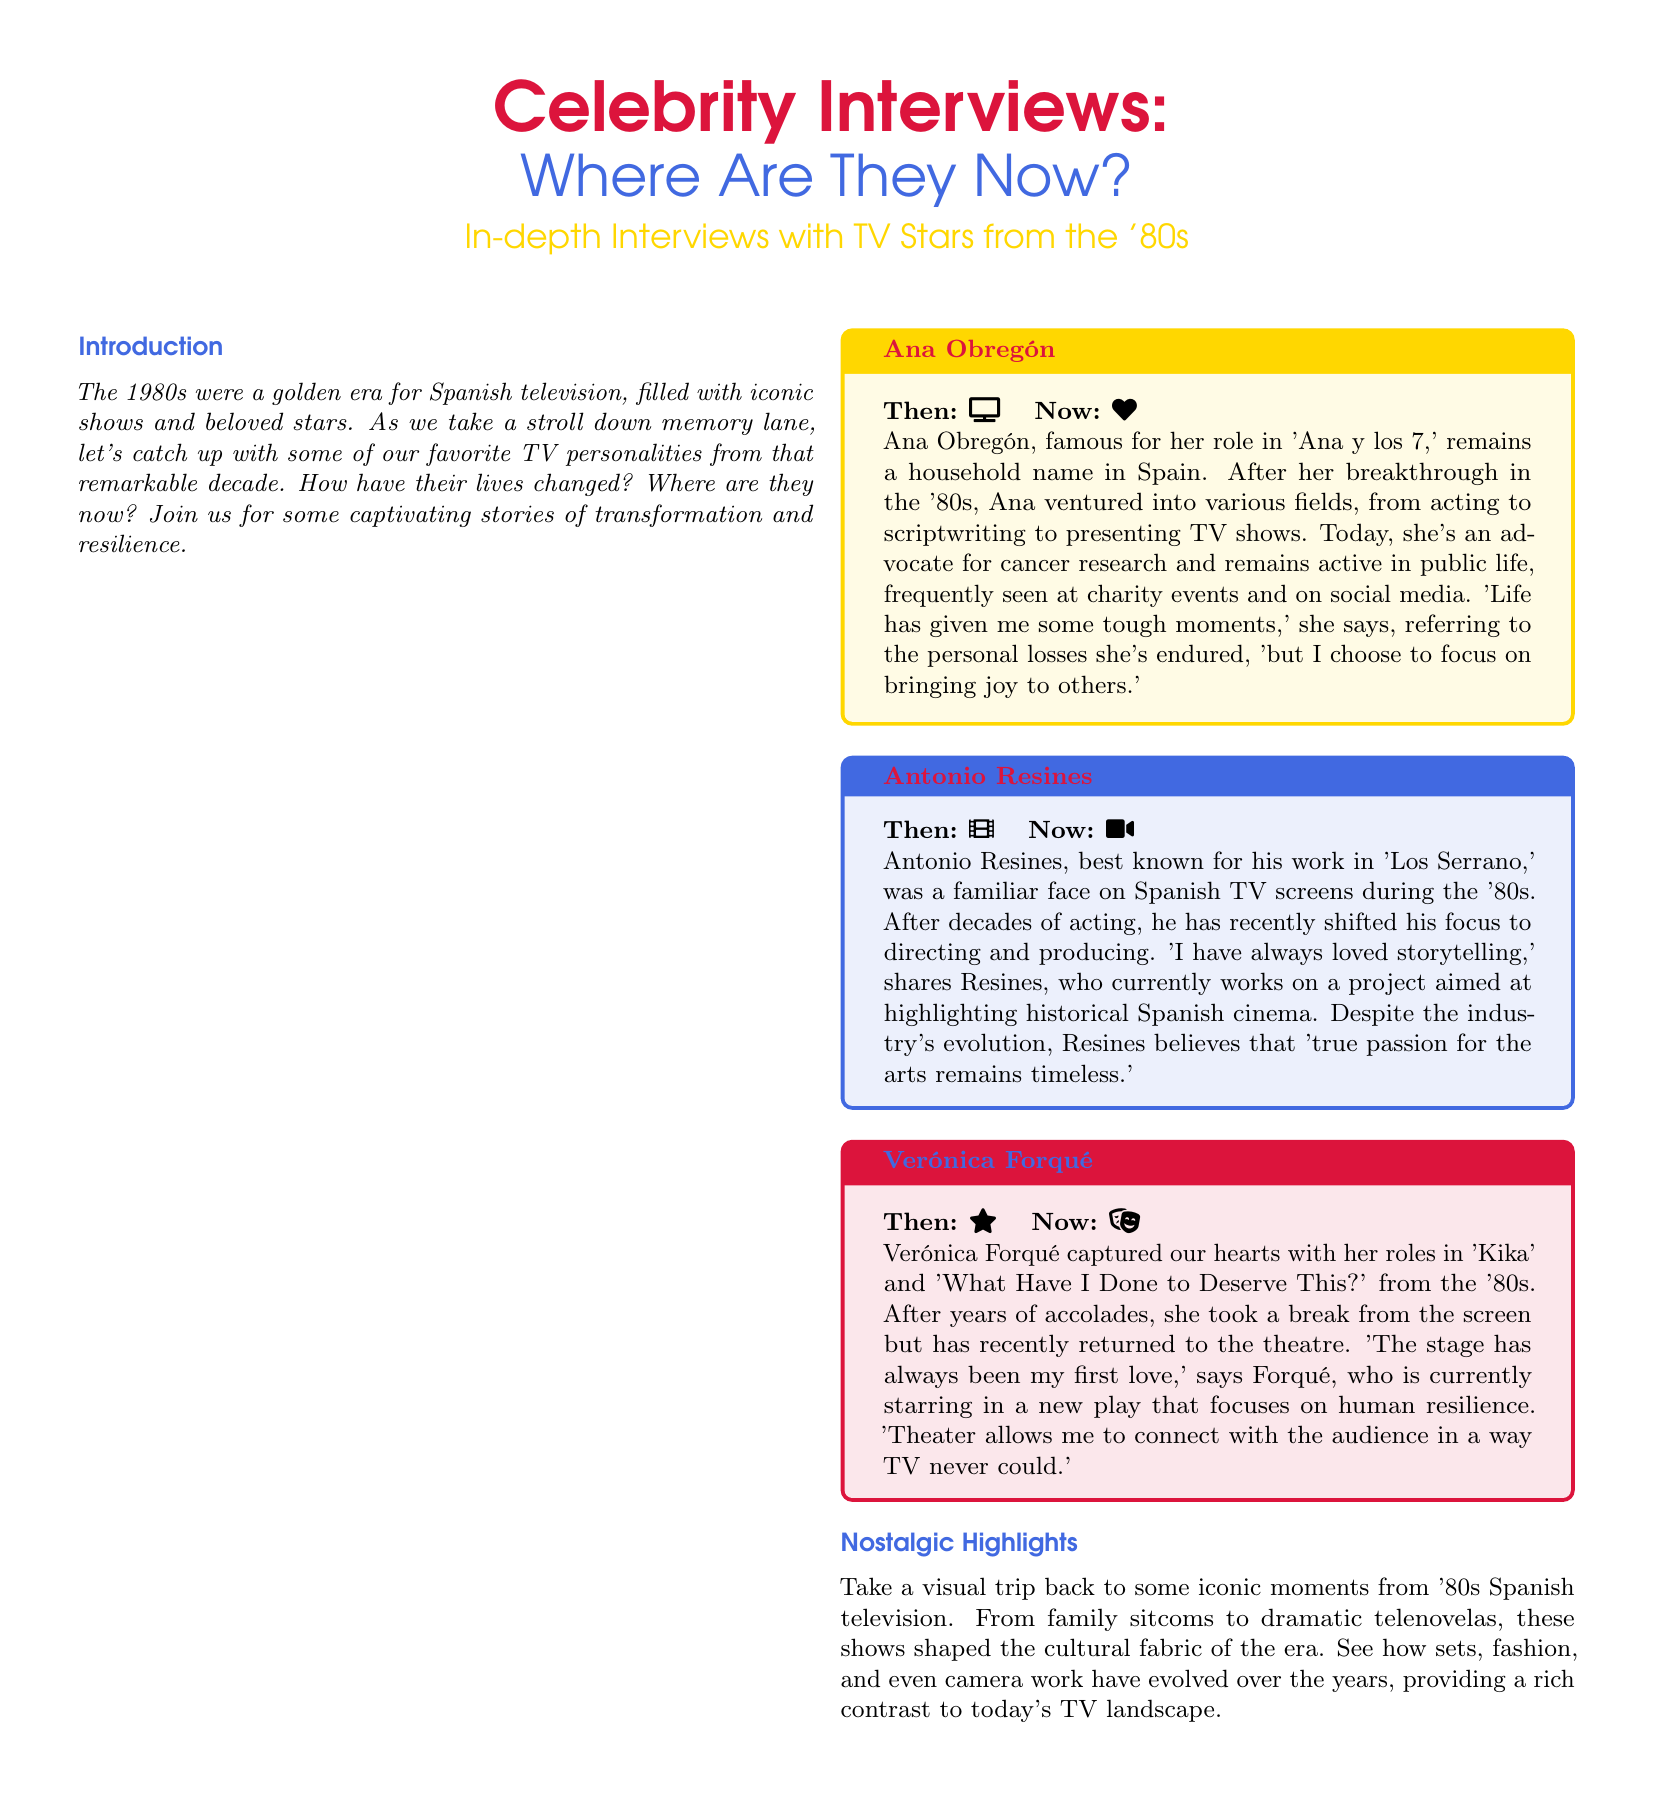What is the title of the magazine feature? The title of the magazine feature is displayed prominently at the top of the document.
Answer: Celebrity Interviews: Where Are They Now? Who is highlighted in the first tcolorbox? The first tcolorbox features a prominent TV star from the '80s, whose name is stated at the top.
Answer: Ana Obregón What is Antonio Resines known for? The document mentions his notable work in a specific television show from the '80s.
Answer: Los Serrano What was Verónica Forqué's first love? This information is mentioned in her quote about her artistic preferences.
Answer: The stage What does Ana Obregón advocate for? The document refers to her current engagement with a specific social cause.
Answer: Cancer research How has Antonio Resines shifted his career focus? The document discusses the area he has recently moved into after acting.
Answer: Directing and producing What type of visuals are included in the nostalgic highlights section? The section highlights specific imagery that connects to the past era of Spanish television.
Answer: Iconic moments What is the color scheme of the magazine layout? The document contains colors named and described in the formatting.
Answer: Nostalgic red, blue, and yellow 